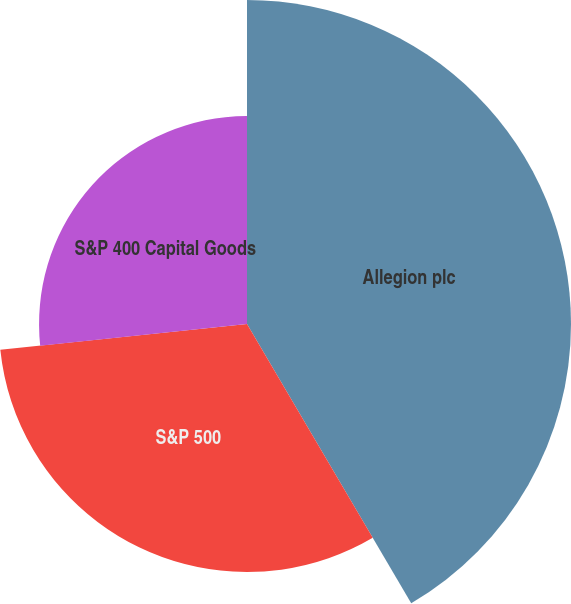Convert chart to OTSL. <chart><loc_0><loc_0><loc_500><loc_500><pie_chart><fcel>Allegion plc<fcel>S&P 500<fcel>S&P 400 Capital Goods<nl><fcel>41.54%<fcel>31.8%<fcel>26.66%<nl></chart> 